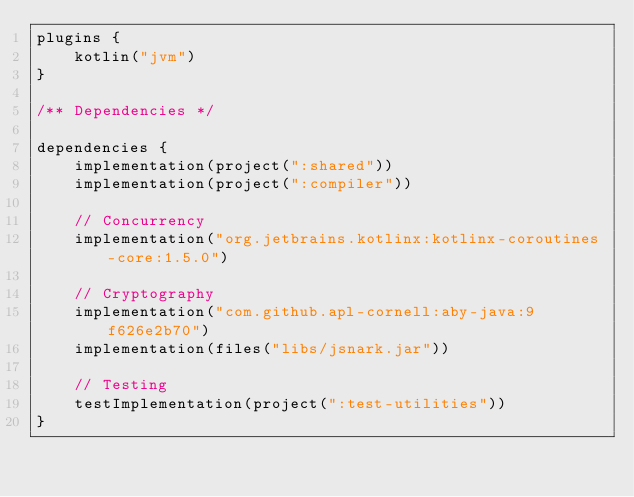Convert code to text. <code><loc_0><loc_0><loc_500><loc_500><_Kotlin_>plugins {
    kotlin("jvm")
}

/** Dependencies */

dependencies {
    implementation(project(":shared"))
    implementation(project(":compiler"))

    // Concurrency
    implementation("org.jetbrains.kotlinx:kotlinx-coroutines-core:1.5.0")

    // Cryptography
    implementation("com.github.apl-cornell:aby-java:9f626e2b70")
    implementation(files("libs/jsnark.jar"))

    // Testing
    testImplementation(project(":test-utilities"))
}
</code> 